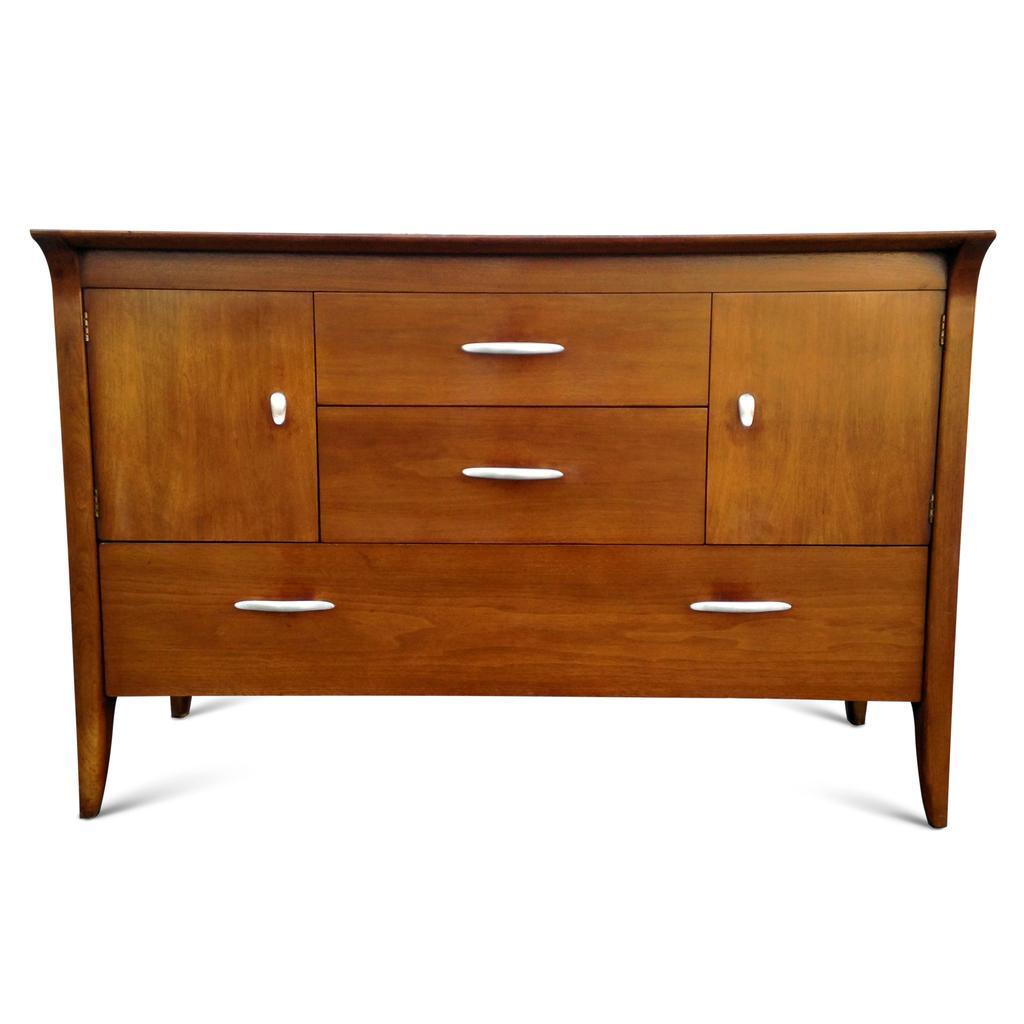How would you summarize this image in a sentence or two? In this image, we can see a wooden table and cupboards. We can see a draws and holders. And we can see a white color holders in the bottom also. 